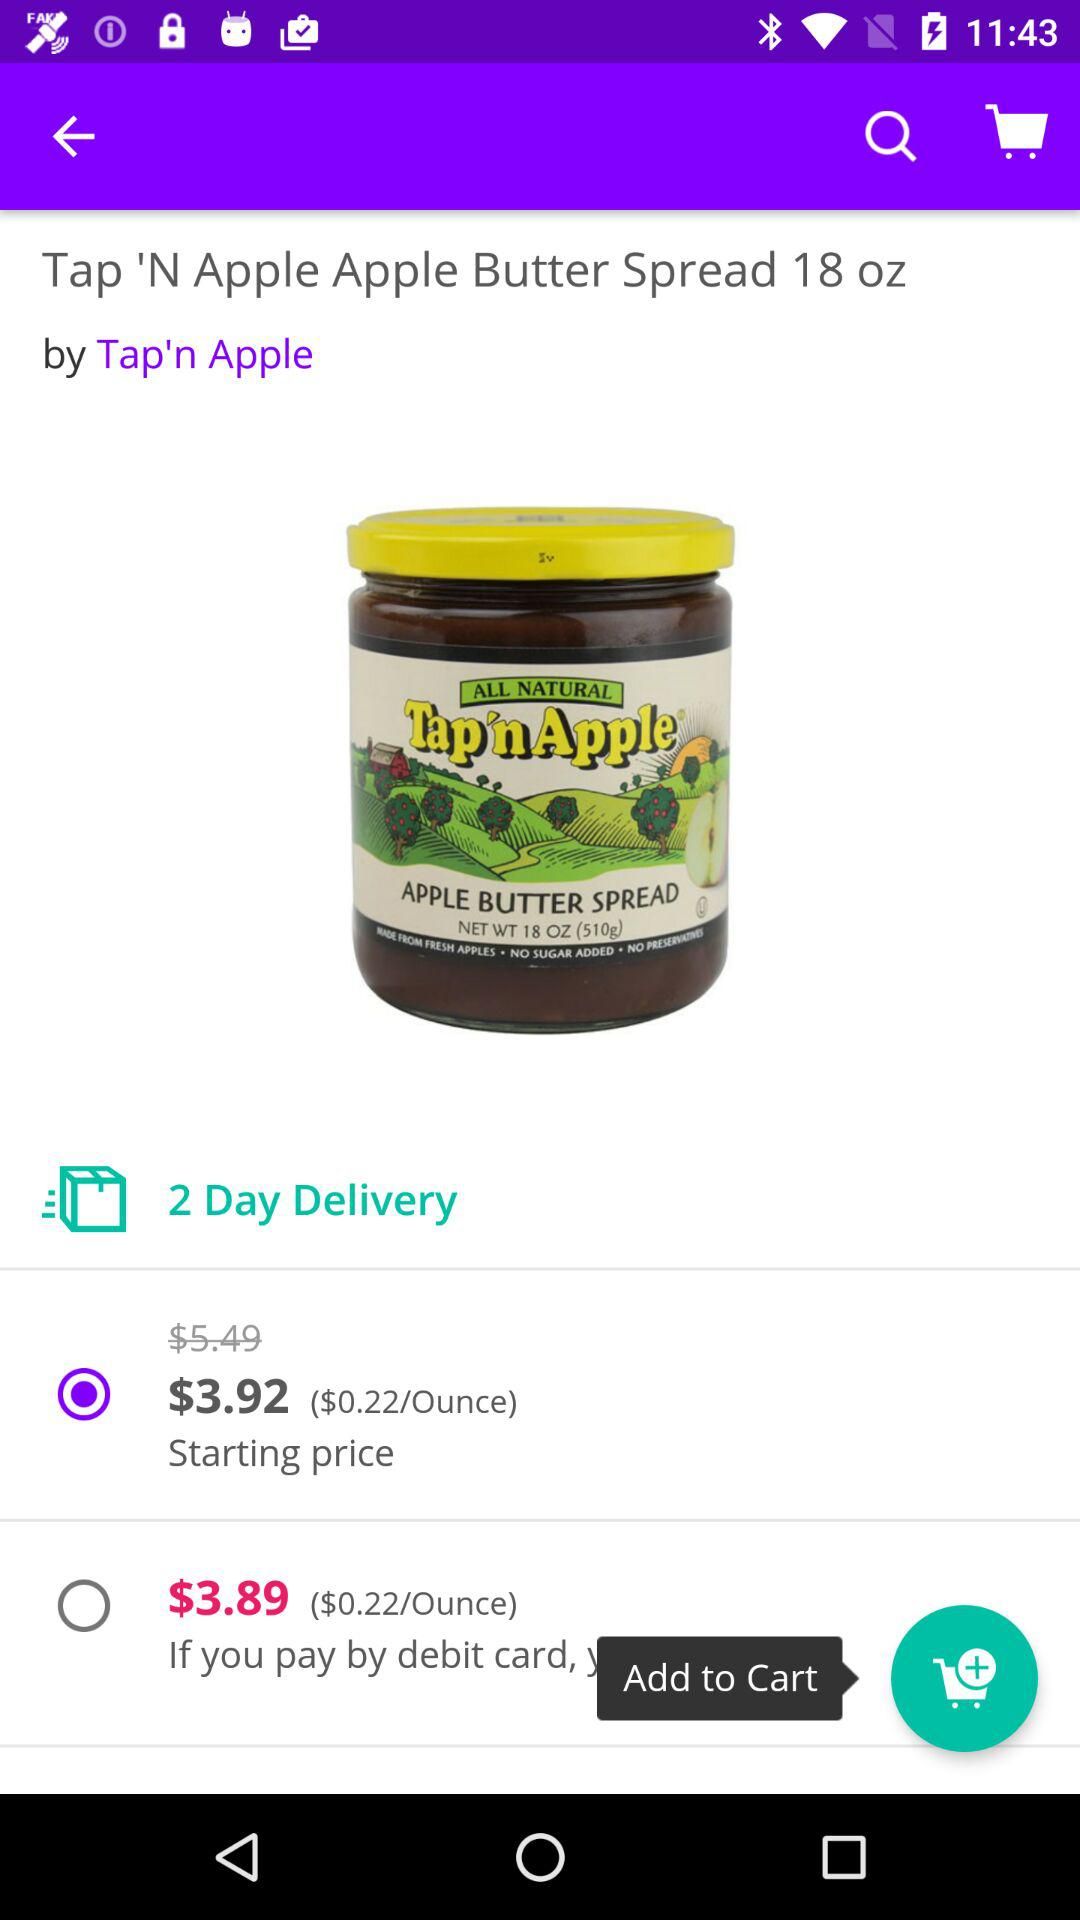How much is the Tap 'N Apple Apple Butter Spread 18 oz if I pay by debit card?
Answer the question using a single word or phrase. $3.89 